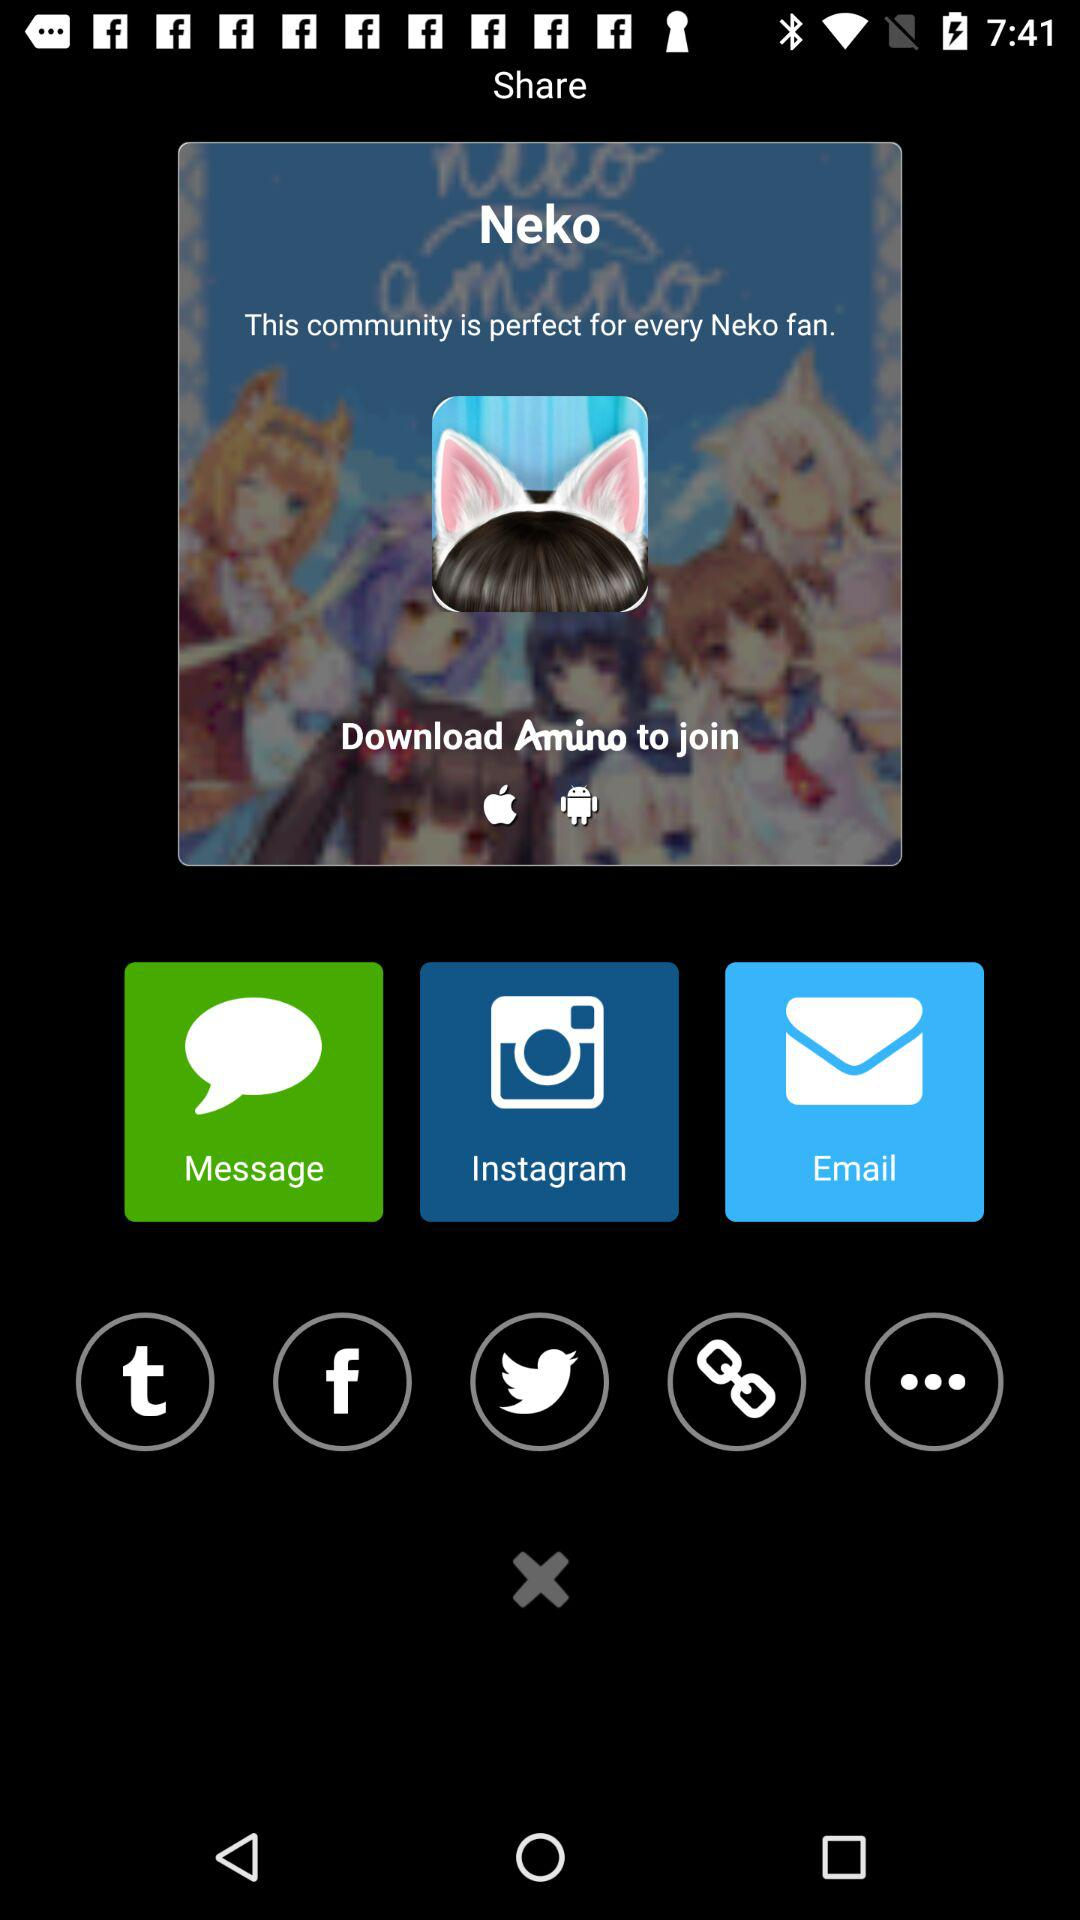What is the user's name?
When the provided information is insufficient, respond with <no answer>. <no answer> 